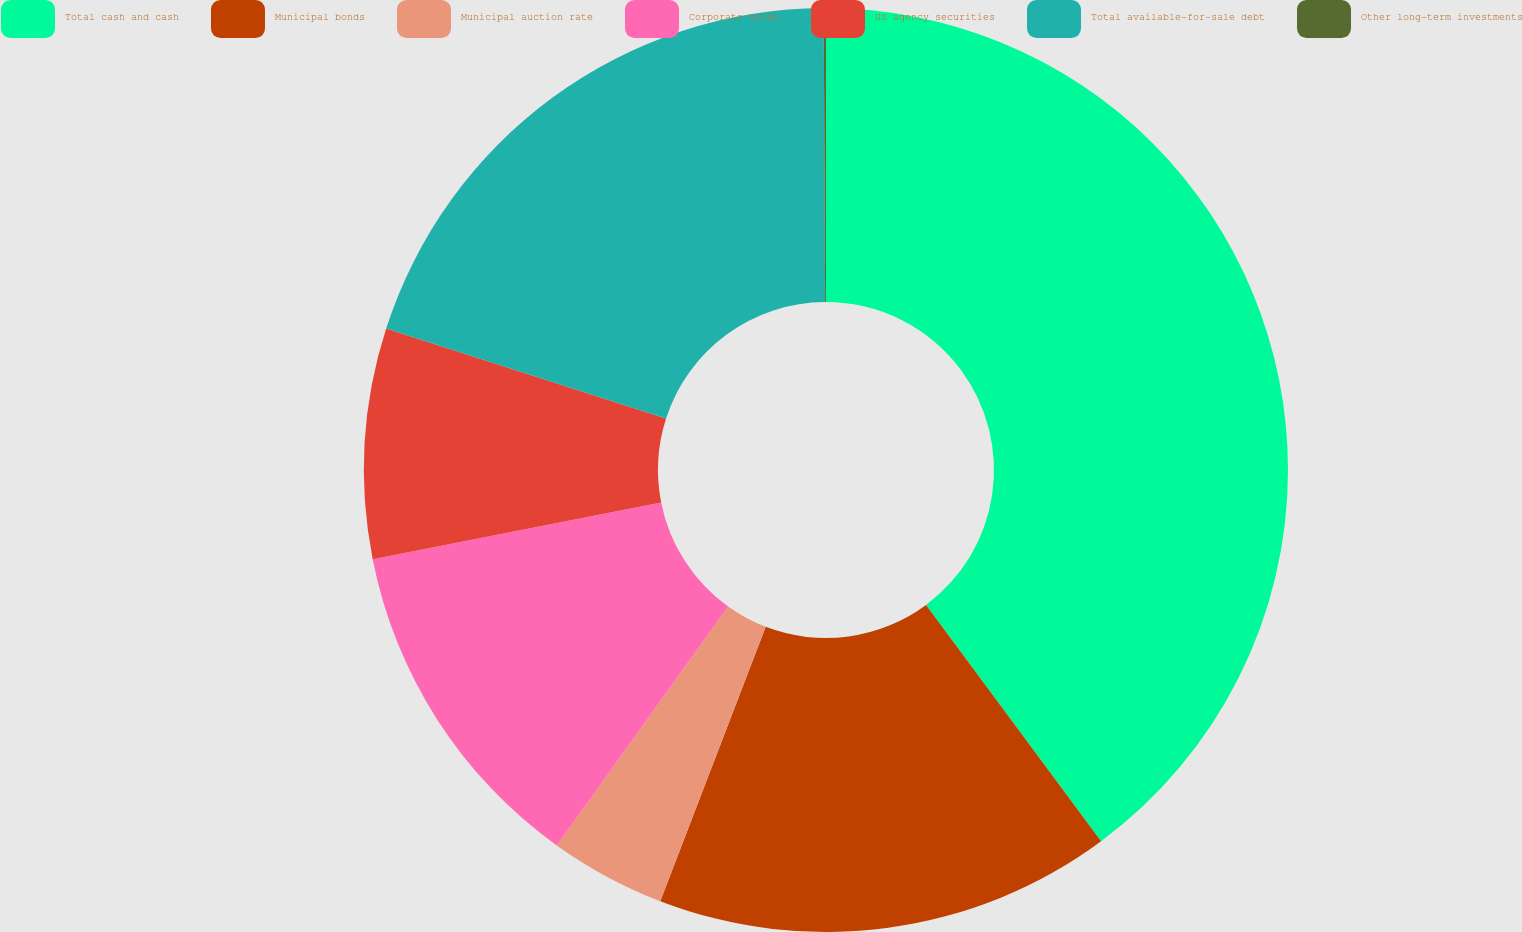Convert chart. <chart><loc_0><loc_0><loc_500><loc_500><pie_chart><fcel>Total cash and cash<fcel>Municipal bonds<fcel>Municipal auction rate<fcel>Corporate notes<fcel>US agency securities<fcel>Total available-for-sale debt<fcel>Other long-term investments<nl><fcel>39.85%<fcel>15.99%<fcel>4.06%<fcel>12.01%<fcel>8.04%<fcel>19.97%<fcel>0.08%<nl></chart> 